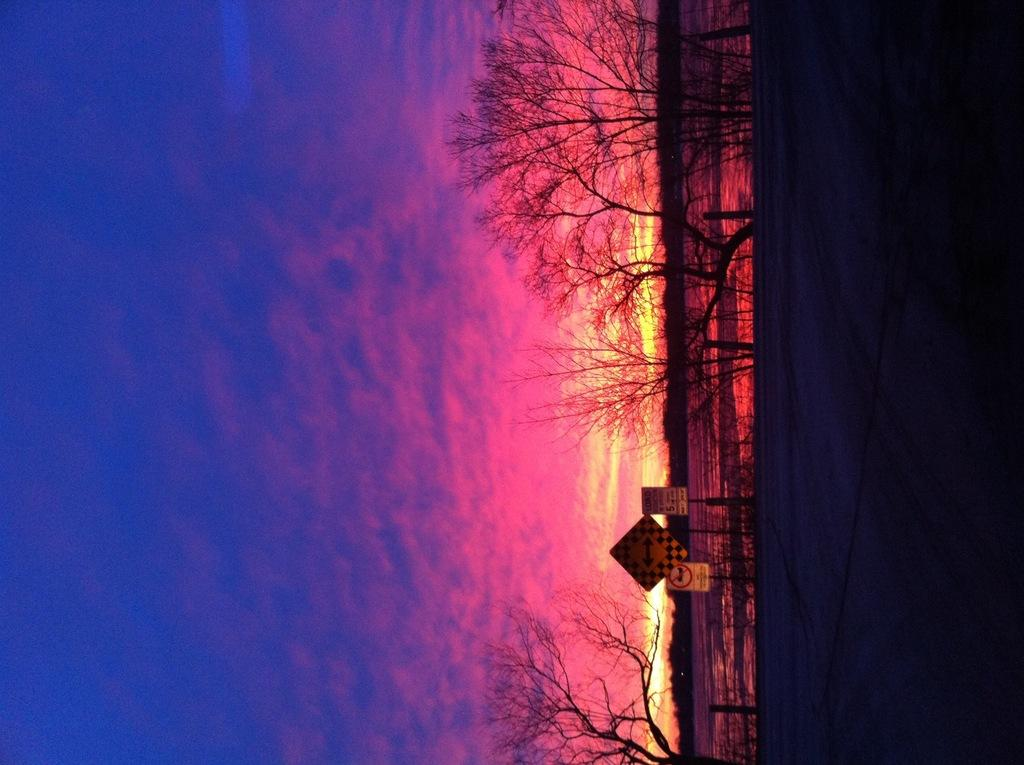What type of surface can be seen in the image? There is ground visible in the image. What structure is present in the image? There is a fence in the image. What safety precautions are taken in the image? Caution boards are present in the image. What type of vegetation is in the image? Dry trees are in the image. How would you describe the lighting in the image? The image is in a dark setting. What can be seen in the background of the image? The sky is visible in the background of the image. What colors are present in the sky? The sky has a pink and blue color. What type of pies are being served on the table in the image? There is no table or pies present in the image. What reward is given to the person who completes the task in the image? There is no task or reward mentioned in the image. What type of quiver is being used by the archer in the image? There is no archer or quiver present in the image. 